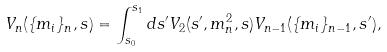Convert formula to latex. <formula><loc_0><loc_0><loc_500><loc_500>V _ { n } ( \{ m _ { i } \} _ { n } , s ) = \int _ { s _ { 0 } } ^ { s _ { 1 } } d s ^ { \prime } { V _ { 2 } ( s ^ { \prime } , m _ { n } ^ { 2 } , s ) V _ { n - 1 } ( \{ m _ { i } \} _ { n - 1 } , s ^ { \prime } ) , }</formula> 